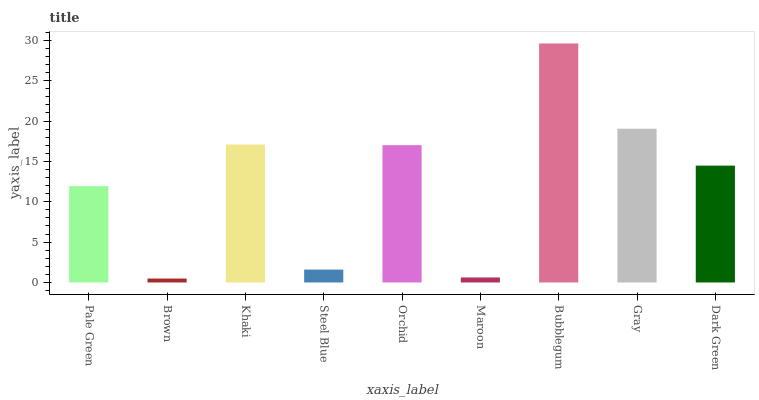Is Khaki the minimum?
Answer yes or no. No. Is Khaki the maximum?
Answer yes or no. No. Is Khaki greater than Brown?
Answer yes or no. Yes. Is Brown less than Khaki?
Answer yes or no. Yes. Is Brown greater than Khaki?
Answer yes or no. No. Is Khaki less than Brown?
Answer yes or no. No. Is Dark Green the high median?
Answer yes or no. Yes. Is Dark Green the low median?
Answer yes or no. Yes. Is Steel Blue the high median?
Answer yes or no. No. Is Steel Blue the low median?
Answer yes or no. No. 